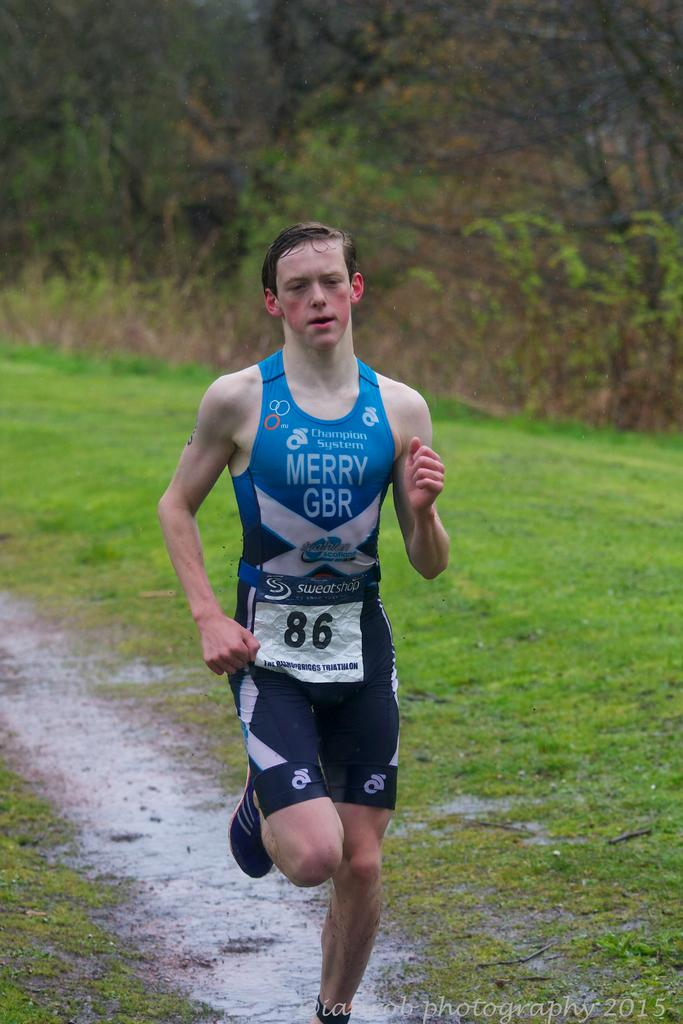<image>
Present a compact description of the photo's key features. Runner # 86 wears a uniform that says Merry GBR while he runs in the rain. 